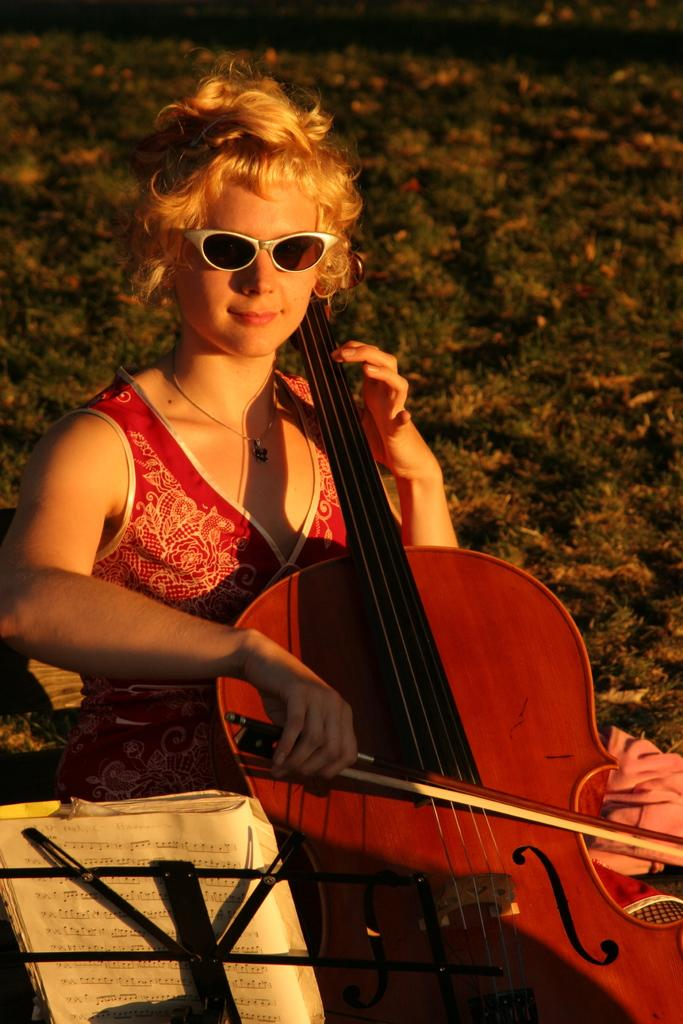Who is the main subject in the image? There is a girl in the image. What is the girl doing in the image? The girl is sitting and playing the violin. Can you describe the girl's appearance? The girl is wearing spectacles. What other objects are near the girl? There is a book and a stand beside the girl. What can be seen in the background of the image? The background of the image is a grassy land. What type of yoke is the girl using to play the violin? There is no yoke present in the image; the girl is playing the violin without any yoke. What kind of band is performing in the background of the image? There is no band present in the image; the background is a grassy land with no musical performance. 